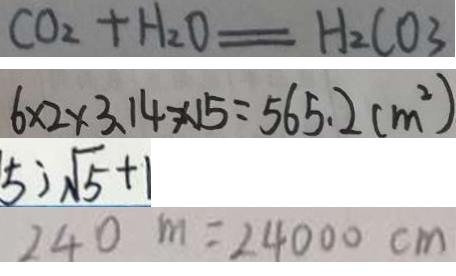<formula> <loc_0><loc_0><loc_500><loc_500>C O _ { 2 } + H _ { 2 } O = H _ { 2 } C O _ { 3 } 
 6 \times 2 \times 3 . 1 4 \times 1 5 = 5 6 5 . 2 ( m ^ { 2 } ) 
 5 ) \sqrt { 5 } + 1 
 2 4 0 m = 2 4 0 0 0 c m</formula> 